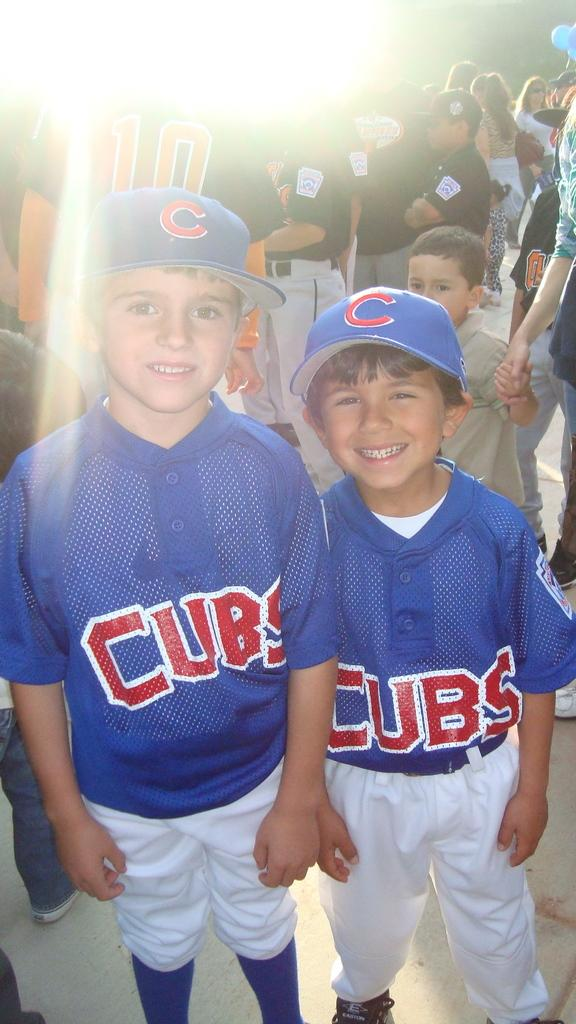<image>
Provide a brief description of the given image. a couple of kids with Cubs jerseys on 